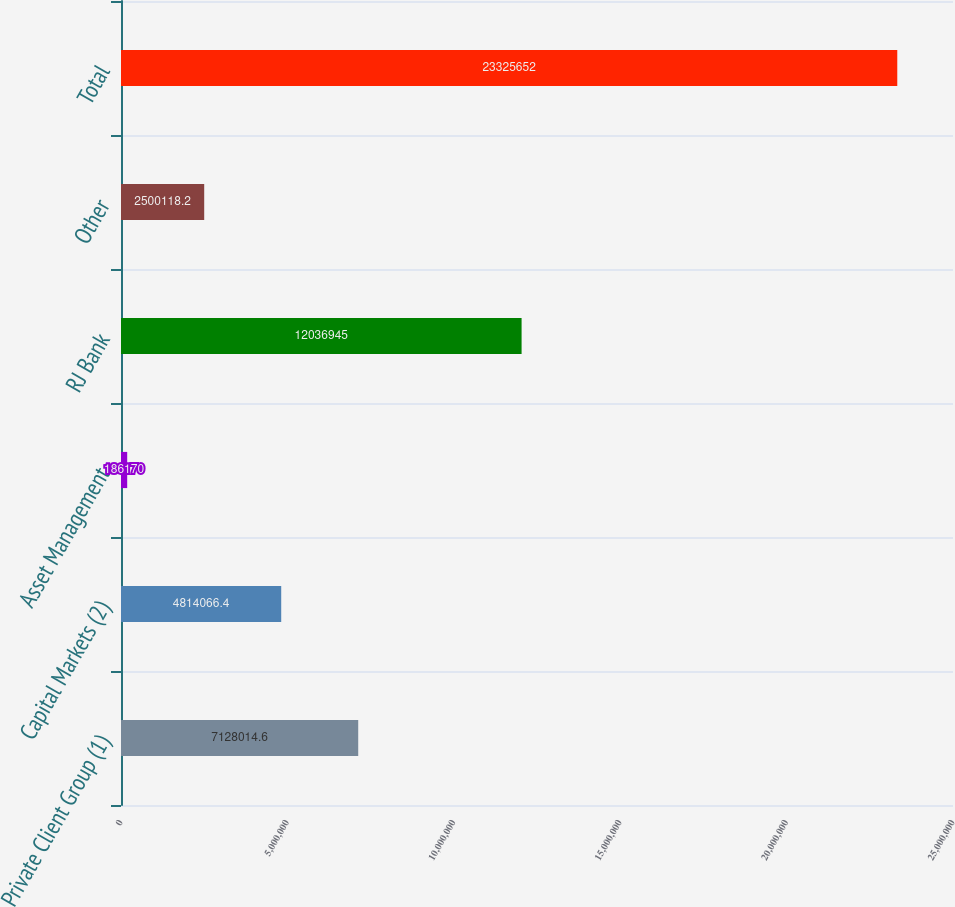Convert chart to OTSL. <chart><loc_0><loc_0><loc_500><loc_500><bar_chart><fcel>Private Client Group (1)<fcel>Capital Markets (2)<fcel>Asset Management<fcel>RJ Bank<fcel>Other<fcel>Total<nl><fcel>7.12801e+06<fcel>4.81407e+06<fcel>186170<fcel>1.20369e+07<fcel>2.50012e+06<fcel>2.33257e+07<nl></chart> 